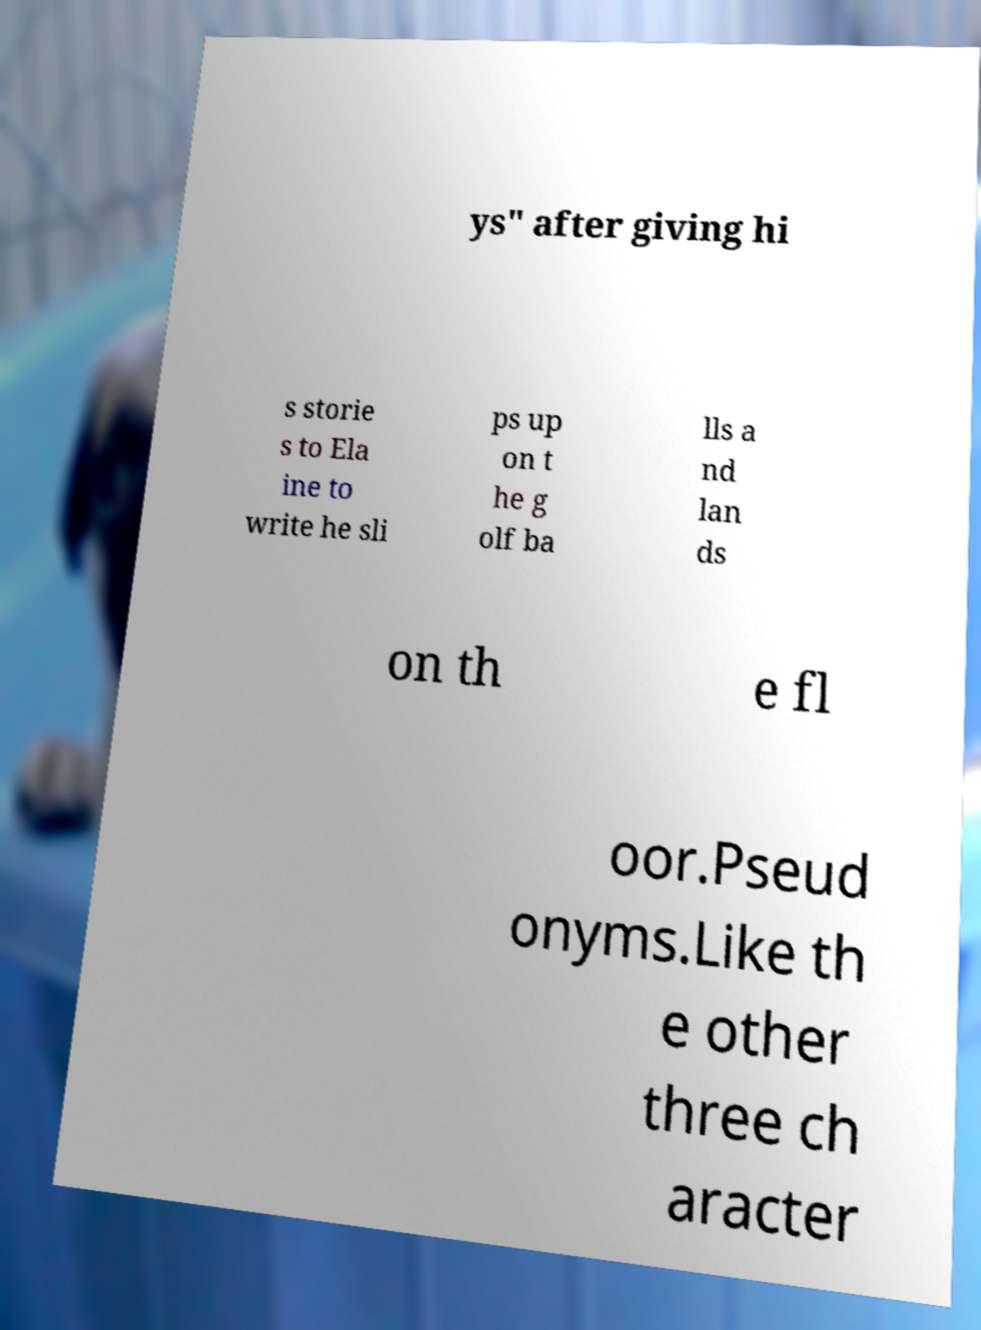Please identify and transcribe the text found in this image. ys" after giving hi s storie s to Ela ine to write he sli ps up on t he g olf ba lls a nd lan ds on th e fl oor.Pseud onyms.Like th e other three ch aracter 